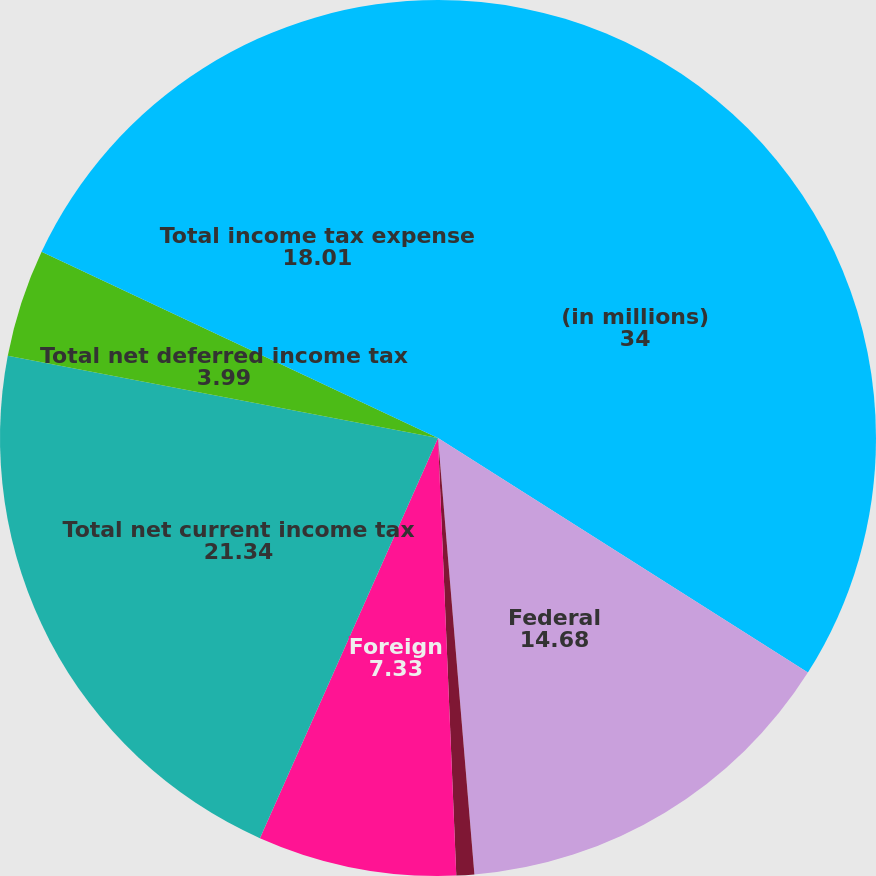Convert chart. <chart><loc_0><loc_0><loc_500><loc_500><pie_chart><fcel>(in millions)<fcel>Federal<fcel>State and local<fcel>Foreign<fcel>Total net current income tax<fcel>Total net deferred income tax<fcel>Total income tax expense<nl><fcel>34.0%<fcel>14.68%<fcel>0.66%<fcel>7.33%<fcel>21.34%<fcel>3.99%<fcel>18.01%<nl></chart> 